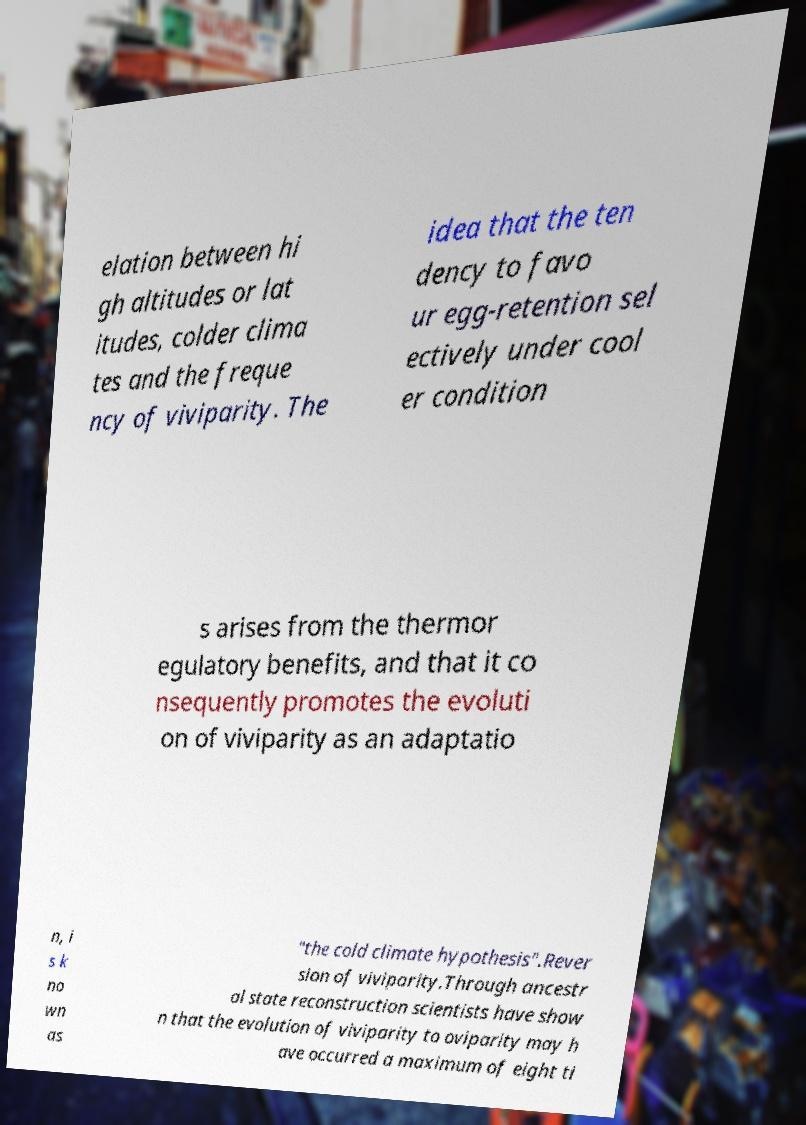Please read and relay the text visible in this image. What does it say? elation between hi gh altitudes or lat itudes, colder clima tes and the freque ncy of viviparity. The idea that the ten dency to favo ur egg-retention sel ectively under cool er condition s arises from the thermor egulatory benefits, and that it co nsequently promotes the evoluti on of viviparity as an adaptatio n, i s k no wn as "the cold climate hypothesis".Rever sion of viviparity.Through ancestr al state reconstruction scientists have show n that the evolution of viviparity to oviparity may h ave occurred a maximum of eight ti 